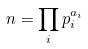<formula> <loc_0><loc_0><loc_500><loc_500>n = \prod _ { i } p _ { i } ^ { a _ { i } }</formula> 